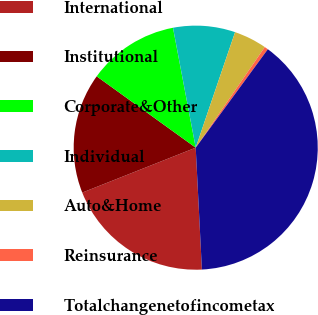<chart> <loc_0><loc_0><loc_500><loc_500><pie_chart><fcel>International<fcel>Institutional<fcel>Corporate&Other<fcel>Individual<fcel>Auto&Home<fcel>Reinsurance<fcel>Totalchangenetofincometax<nl><fcel>19.81%<fcel>15.94%<fcel>12.08%<fcel>8.21%<fcel>4.35%<fcel>0.49%<fcel>39.13%<nl></chart> 